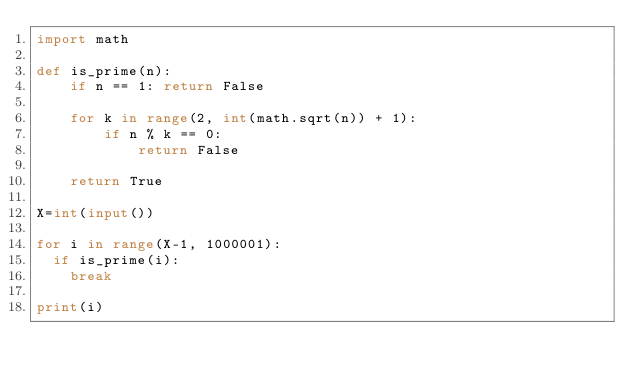<code> <loc_0><loc_0><loc_500><loc_500><_Python_>import math

def is_prime(n):
    if n == 1: return False

    for k in range(2, int(math.sqrt(n)) + 1):
        if n % k == 0:
            return False

    return True

X=int(input())

for i in range(X-1, 1000001):
  if is_prime(i):
    break
    
print(i)</code> 